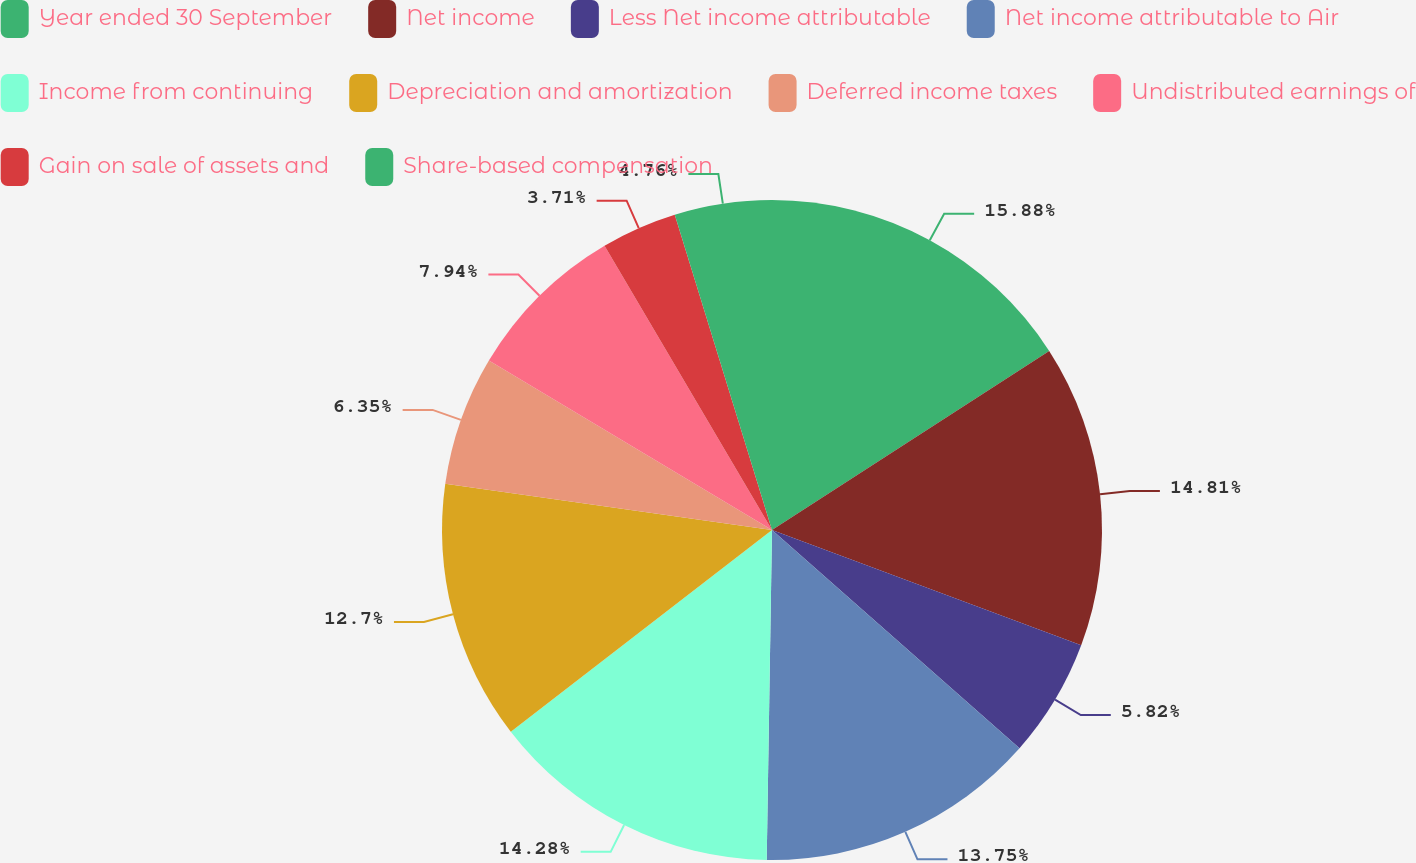Convert chart to OTSL. <chart><loc_0><loc_0><loc_500><loc_500><pie_chart><fcel>Year ended 30 September<fcel>Net income<fcel>Less Net income attributable<fcel>Net income attributable to Air<fcel>Income from continuing<fcel>Depreciation and amortization<fcel>Deferred income taxes<fcel>Undistributed earnings of<fcel>Gain on sale of assets and<fcel>Share-based compensation<nl><fcel>15.87%<fcel>14.81%<fcel>5.82%<fcel>13.75%<fcel>14.28%<fcel>12.7%<fcel>6.35%<fcel>7.94%<fcel>3.71%<fcel>4.76%<nl></chart> 